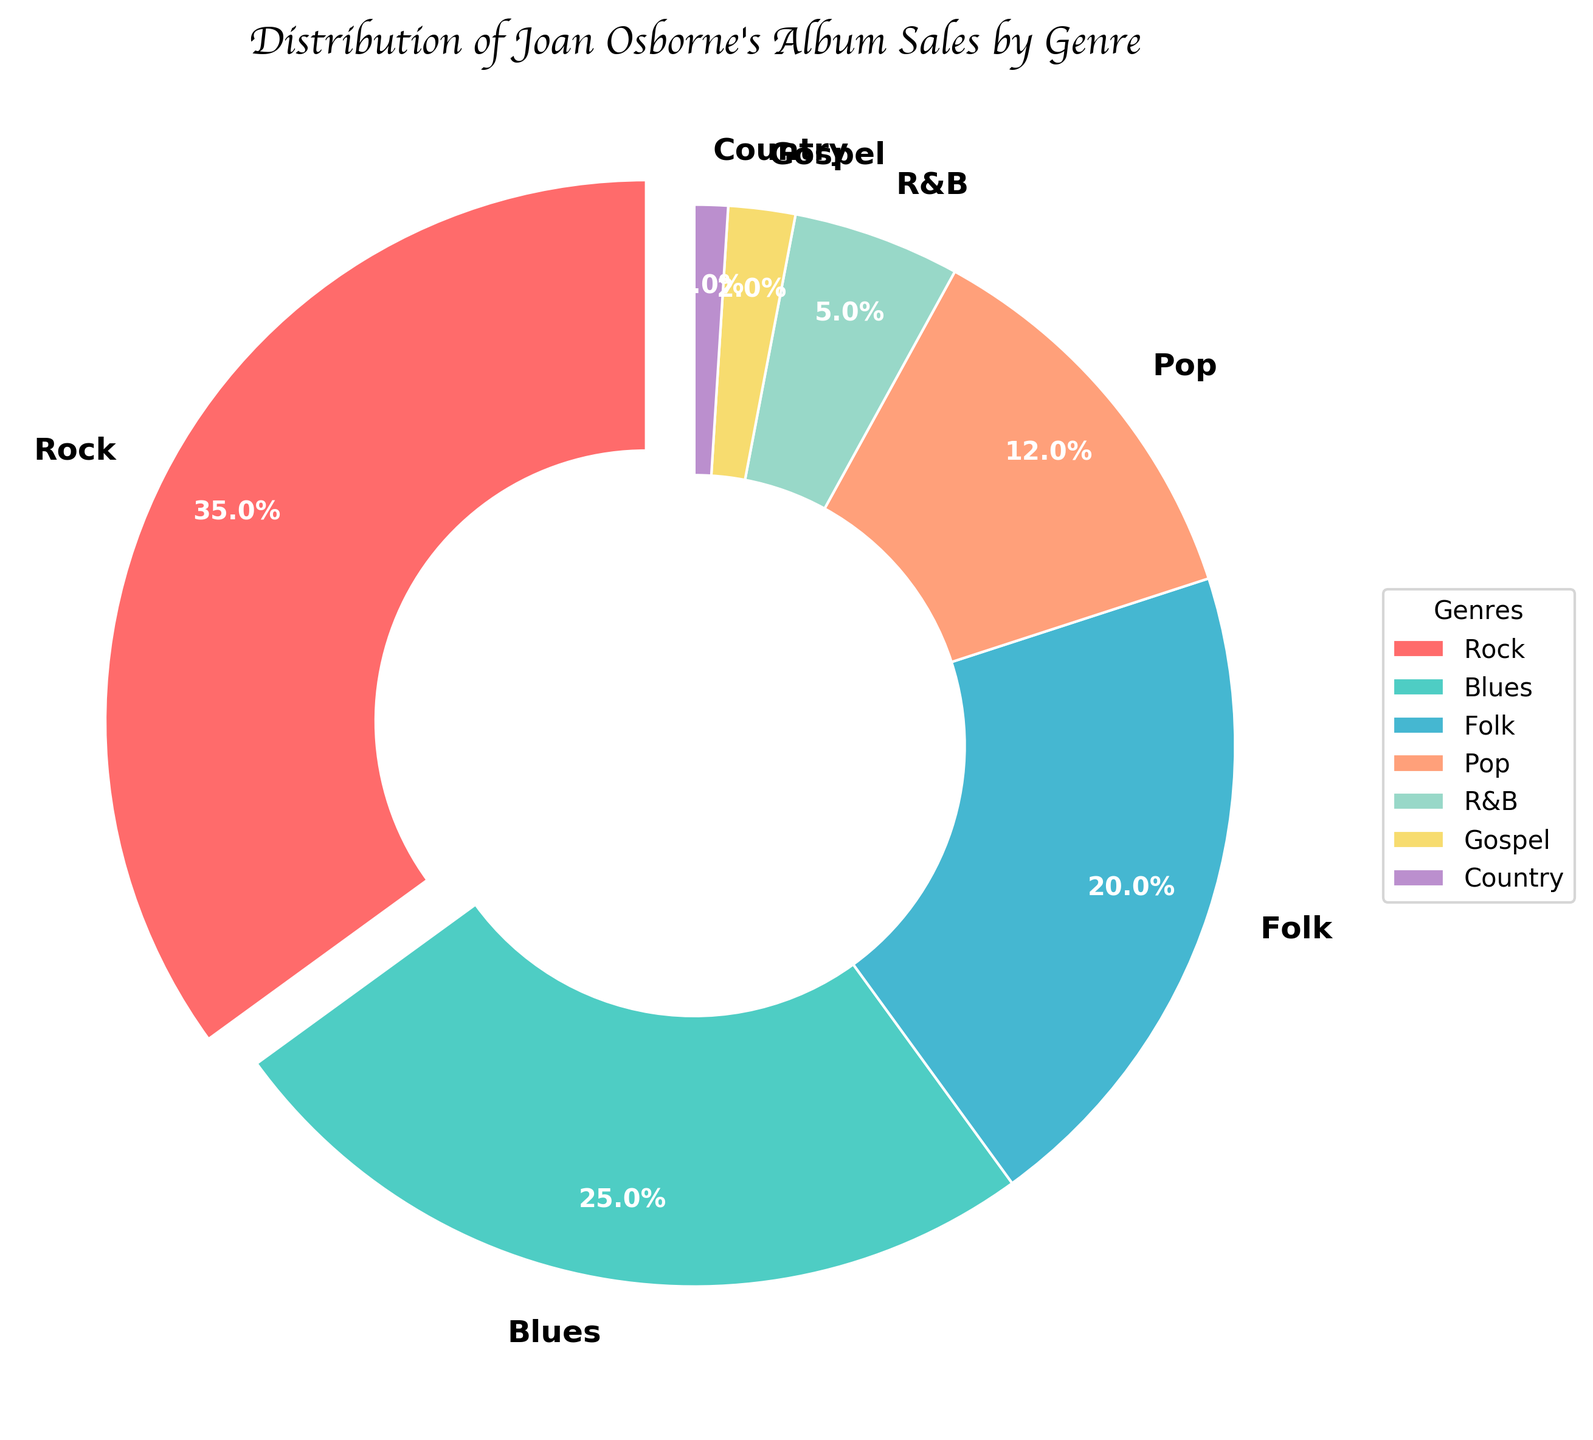What's the genre with the highest album sales as per the pie chart? The pie chart clearly shows the largest slice with 35% labeled as Rock. Therefore, Rock is the genre with the highest album sales.
Answer: Rock Which genre has a larger percentage of album sales, Folk or Pop? By looking at the percentages on the pie chart, Folk is labeled as 20% and Pop is labeled as 12%. Since 20% is greater than 12%, Folk has a larger percentage of album sales.
Answer: Folk How much more percentage do Blues and Rock together contribute to album sales compared to the combined percentage of Pop and Gospel? Blues is 25% and Rock is 35%, their sum is 25% + 35% = 60%. Pop is 12% and Gospel is 2%, their sum is 12% + 2% = 14%. The difference is 60% - 14% = 46%.
Answer: 46% What's the total percentage of album sales contributed by Rock, Folk, and R&B genres combined? From the pie chart, Rock is 35%, Folk is 20%, and R&B is 5%. Adding these together, 35% + 20% + 5% equals 60%.
Answer: 60% What is the total album sales percentage for the genres shown in the pie chart? The pie chart percentages add up to the total album sales. Adding all the slices together: 35% + 25% + 20% + 12% + 5% + 2% + 1% = 100%.
Answer: 100% Which genre occupies the smallest slice in the pie chart? The smallest slice labeled in the pie chart is 1%, which corresponds to the Country genre.
Answer: Country Which genre has the darkest colored slice in the pie chart? The pie chart is visually shaded with different colors. The darkest colored slice appears to be the Blues genre, represented with a darker color.
Answer: Blues How much larger is the percentage of album sales in Rock than in R&B? According to the pie chart, Rock is at 35% and R&B is at 5%. The difference between them is 35% - 5% = 30%.
Answer: 30% 